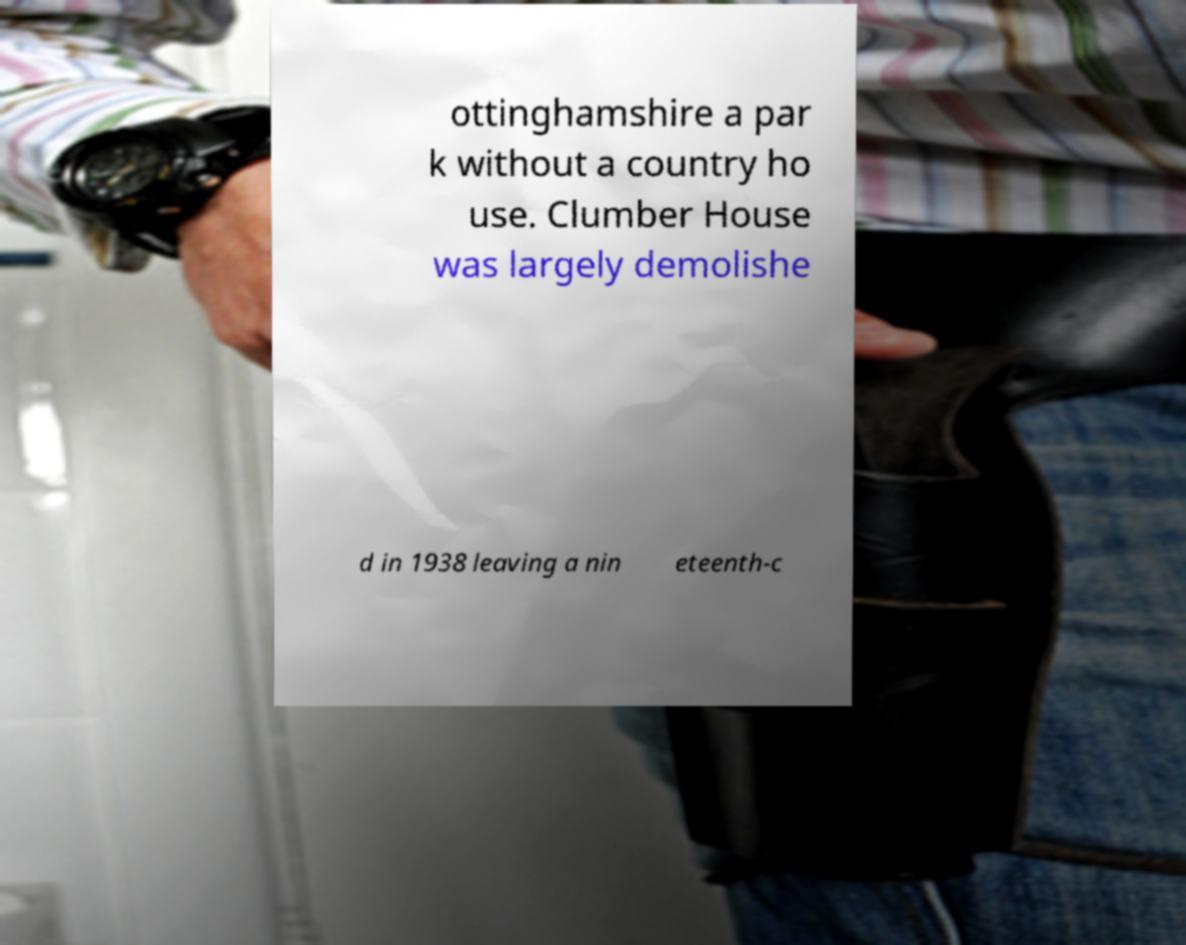Can you accurately transcribe the text from the provided image for me? ottinghamshire a par k without a country ho use. Clumber House was largely demolishe d in 1938 leaving a nin eteenth-c 